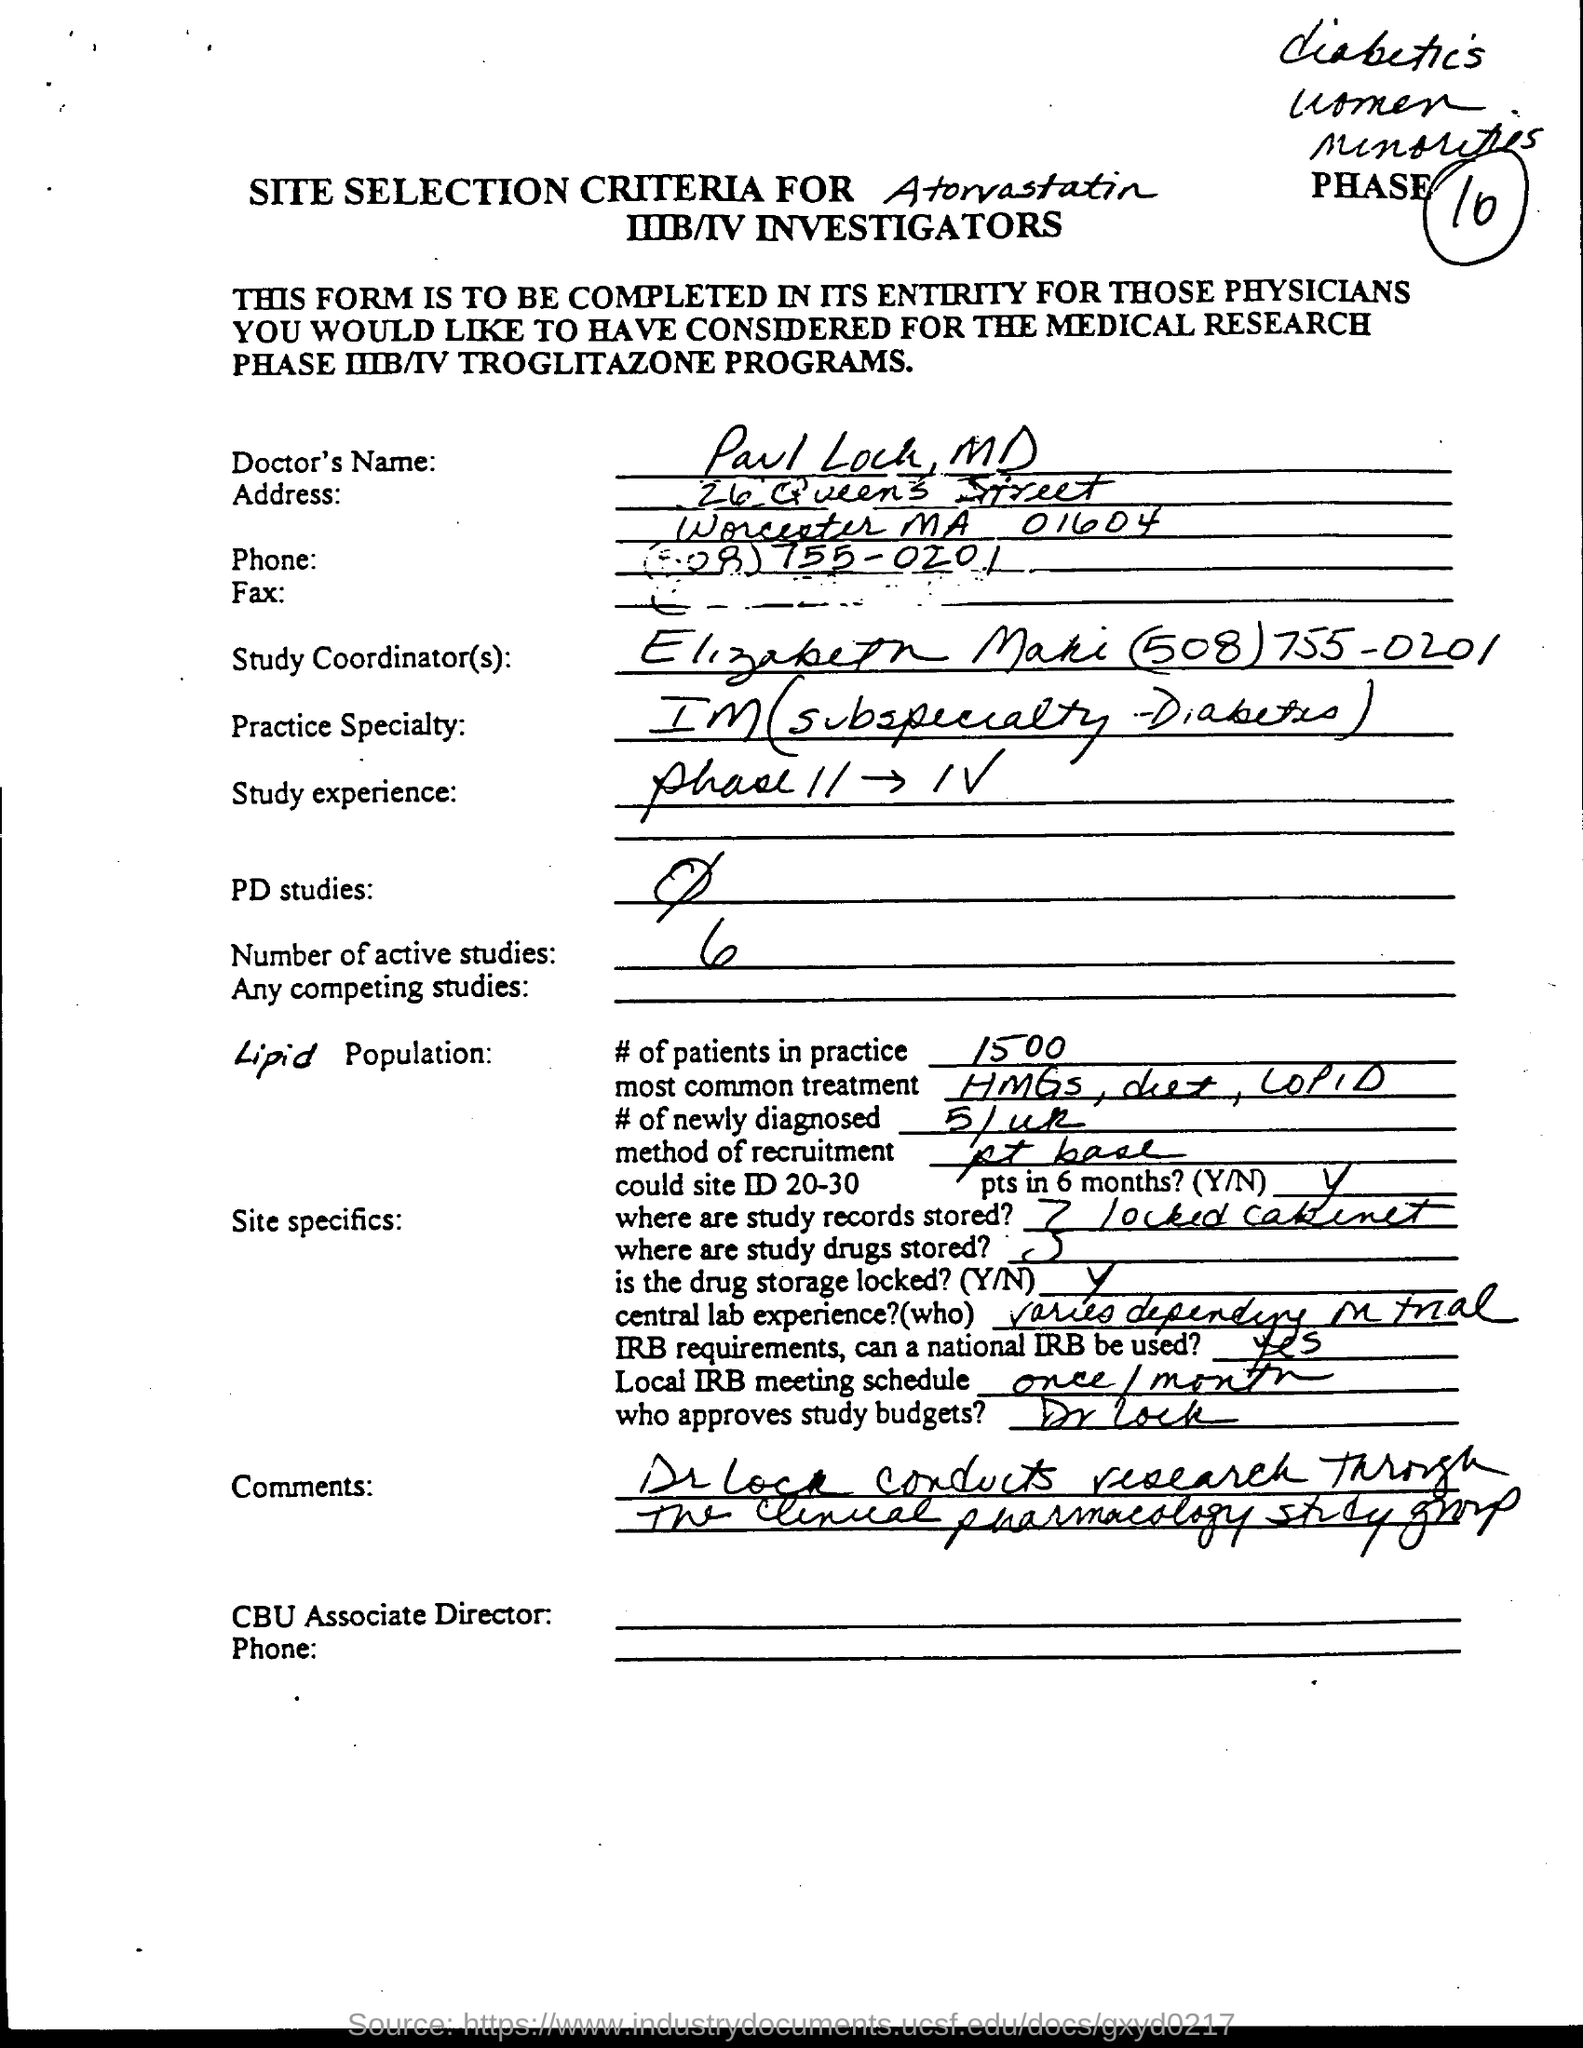Draw attention to some important aspects in this diagram. The Study Experience, phase II, III, and IV, refers to a series of educational programs designed to enhance the learning experience of students through interactive and engaging activities. The number of patients in the practice is approximately 1500. The number of active studies is 6. The specialty of the practice is Internal Medicine with a subspecialty in Diabetes. It is Dr. Lock who approves study budgets. 